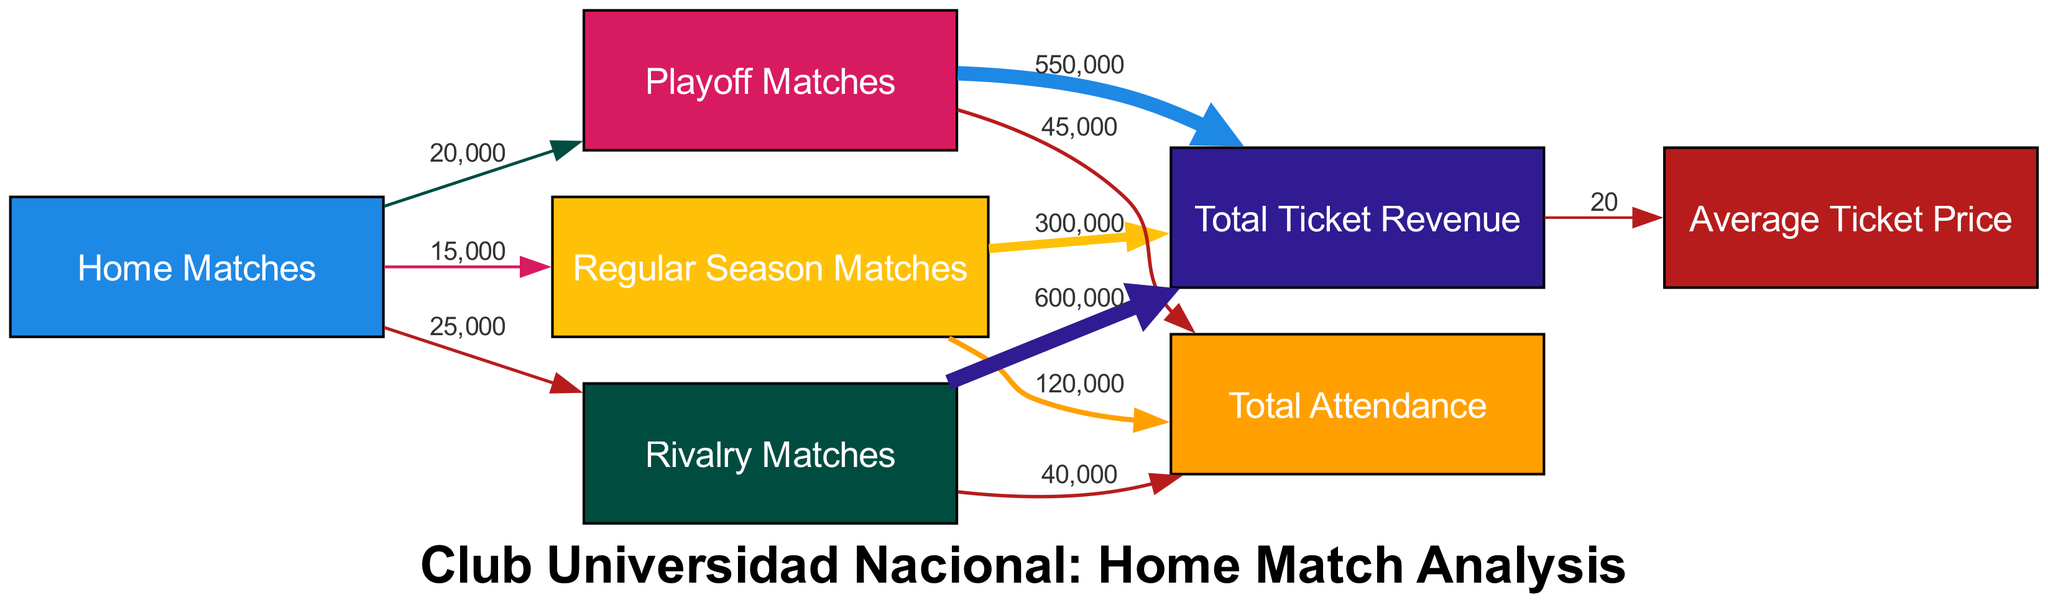What is the total attendance for Regular Season Matches? The node "Regular Season" connects to "Attendance" with a value of 120000. This indicates that the total attendance recorded for Regular Season Matches is directly represented by that value.
Answer: 120000 How much ticket revenue is generated from Rivalry Matches? Looking at the link from "Rivalry Matches" to "Ticket Revenue", the value indicated is 600000. This shows the total ticket revenue specifically from Rivalry Matches.
Answer: 600000 Which match type has the highest attendance? By examining the attendance values linked to each match type, Rivalry Matches have a value of 40000, Playoff Matches have 45000, and Regular Season Matches have 120000; Regular Season produces the highest attendance.
Answer: Regular Season Matches What is the average ticket price based on total ticket revenue? The diagram shows a link from "Ticket Revenue" to "Average Ticket Price" with a value of 20. This indicates that the average ticket price calculated across all matches is represented by this value.
Answer: 20 How many home matches are categorized as Playoffs? The link from "Home Matches" to "Playoffs" indicates a value of 20000. This value represents the number of home matches classified as playoff matches.
Answer: 20000 What is the total ticket revenue for all home matches combined? To find the total ticket revenue, we can sum the ticket revenues from each match type: Regular Season (300000), Playoffs (550000), and Rivalry Matches (600000). Therefore, the total revenue is 300000 + 550000 + 600000.
Answer: 1450000 How many different match types are represented in the diagram? The diagram shows three match types: Regular Season Matches, Playoff Matches, and Rivalry Matches. Each of these is represented distinctly by a node.
Answer: 3 Which match type contributes the most to total attendance? Attendance values are compared: Regular Season Matches (120000), Playoff Matches (45000), and Rivalry Matches (40000). The matchup with the highest attendance is Regular Season Matches.
Answer: Regular Season Matches What is the relationship between average ticket price and ticket revenue? The link from "Ticket Revenue" to "Average Ticket Price" provides a value of 20 but does not indicate a numeric relationship. However, it implies that ticket revenue is derived from the average ticket price when multiplied by the number of tickets sold.
Answer: Direct correlation How many times greater is the ticket revenue from Rivalry Matches compared to Playoff Matches? To calculate this, take the ticket revenue from Rivalry Matches (600000) and divide it by the ticket revenue from Playoff Matches (550000). This yields approximately 1.09, meaning Rivalry Matches generate slightly more revenue than Playoff Matches.
Answer: 1.09 